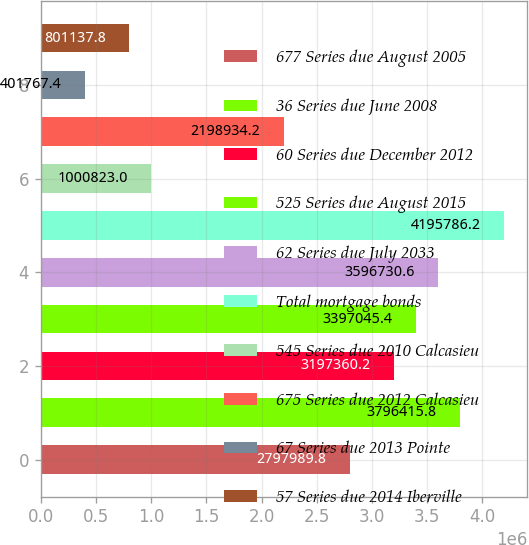<chart> <loc_0><loc_0><loc_500><loc_500><bar_chart><fcel>677 Series due August 2005<fcel>36 Series due June 2008<fcel>60 Series due December 2012<fcel>525 Series due August 2015<fcel>62 Series due July 2033<fcel>Total mortgage bonds<fcel>545 Series due 2010 Calcasieu<fcel>675 Series due 2012 Calcasieu<fcel>67 Series due 2013 Pointe<fcel>57 Series due 2014 Iberville<nl><fcel>2.79799e+06<fcel>3.79642e+06<fcel>3.19736e+06<fcel>3.39705e+06<fcel>3.59673e+06<fcel>4.19579e+06<fcel>1.00082e+06<fcel>2.19893e+06<fcel>401767<fcel>801138<nl></chart> 